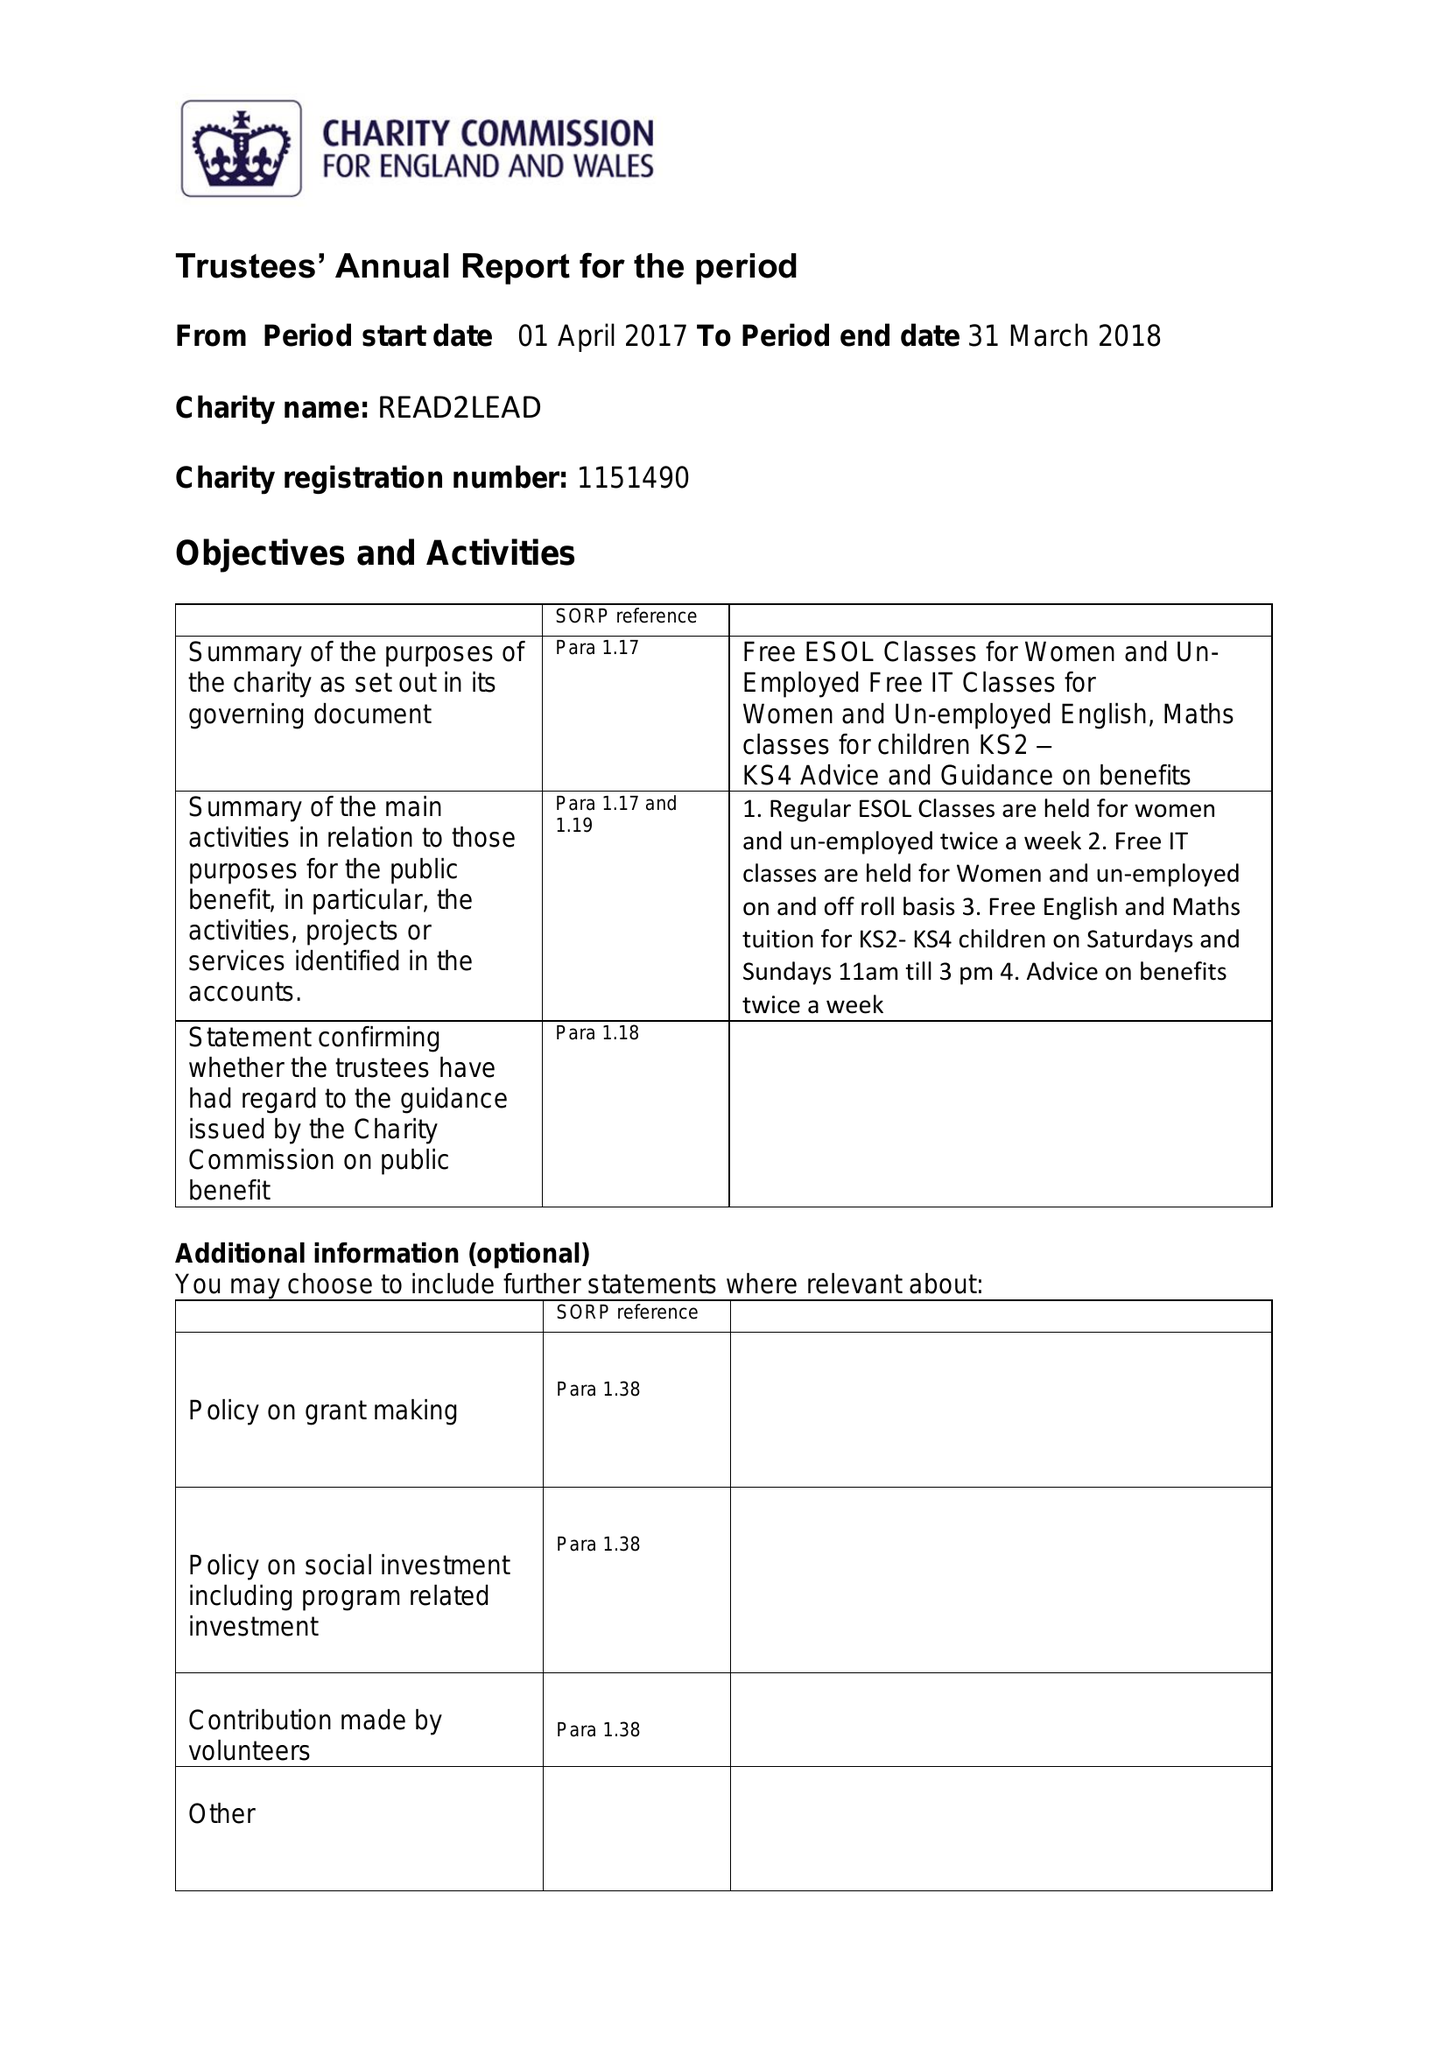What is the value for the charity_name?
Answer the question using a single word or phrase. Read2lead 